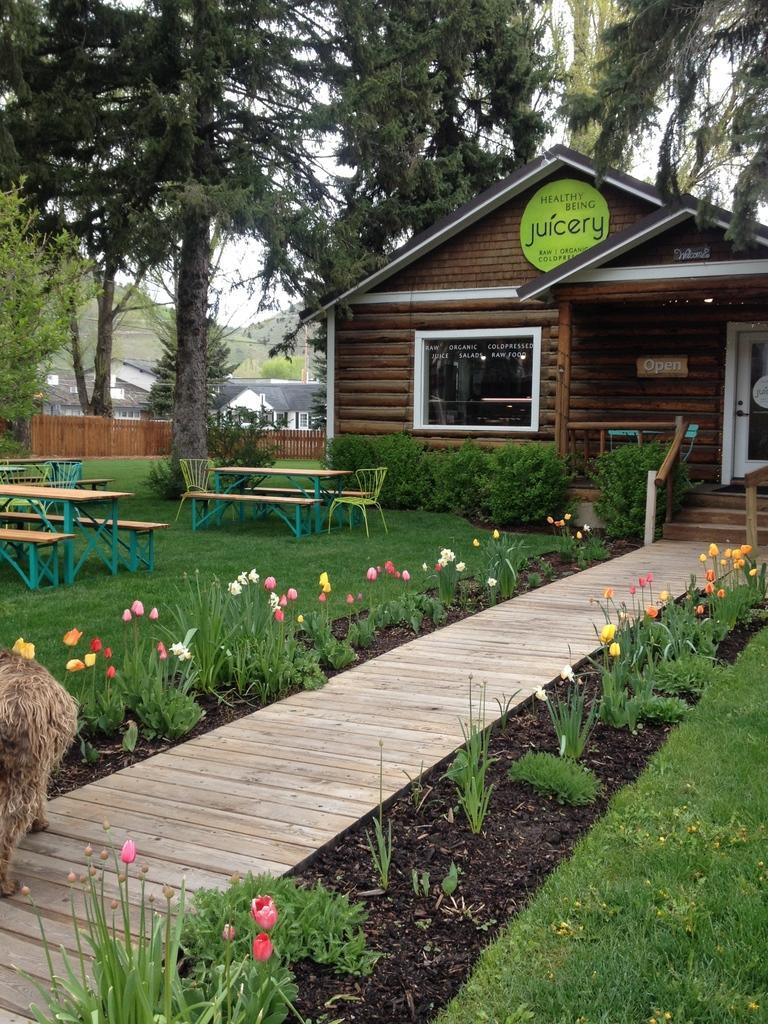Describe this image in one or two sentences. In the picture there is a brown coffee shop. In the front walking area with beautiful flowers on both the side. On the left side we can see the sitting area with some table and benches. Behind there are some trees in the the background. 